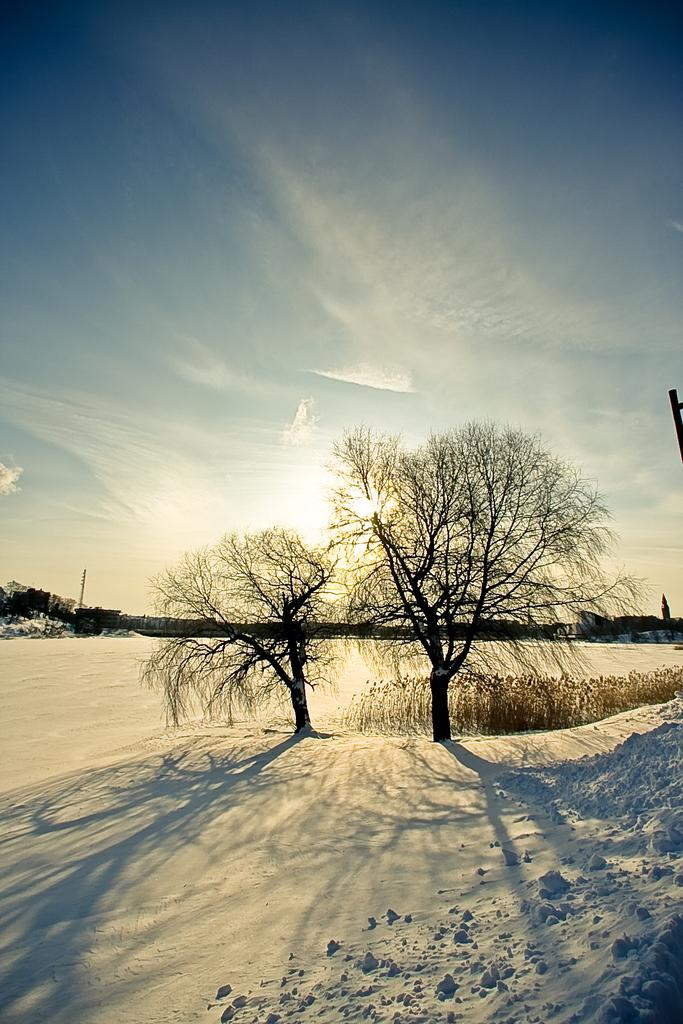What type of vegetation can be seen in the image? There are trees in the image. What is the weather like in the image? There is snow in the image, indicating a cold or wintery setting. What colors can be seen in the sky in the image? The sky is blue and white in color. How many children are playing with the letter-shaped cake in the image? There are no children or cake present in the image; it only features trees, snow, and a blue and white sky. 